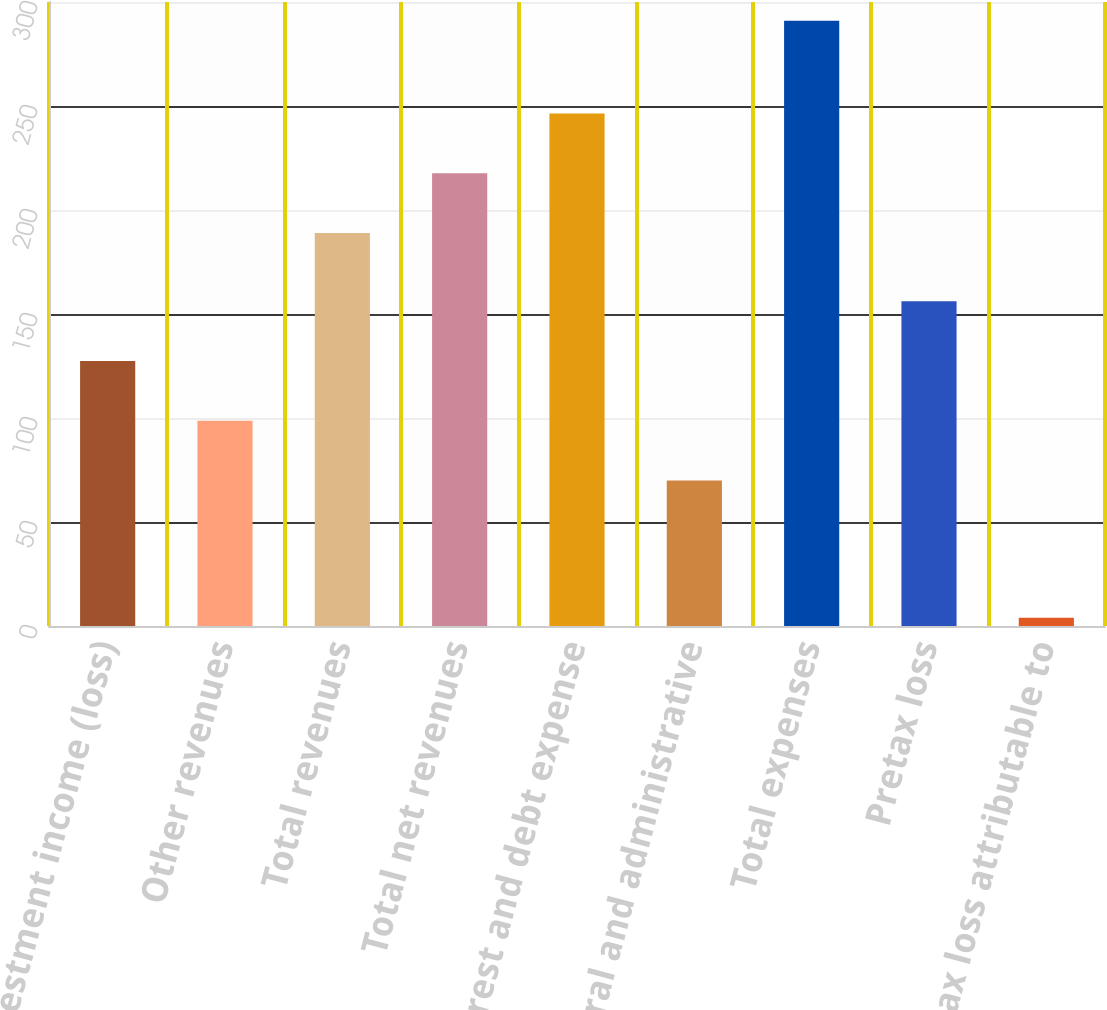Convert chart to OTSL. <chart><loc_0><loc_0><loc_500><loc_500><bar_chart><fcel>Net investment income (loss)<fcel>Other revenues<fcel>Total revenues<fcel>Total net revenues<fcel>Interest and debt expense<fcel>General and administrative<fcel>Total expenses<fcel>Pretax loss<fcel>Pretax loss attributable to<nl><fcel>127.4<fcel>98.7<fcel>189<fcel>217.7<fcel>246.4<fcel>70<fcel>291<fcel>156.1<fcel>4<nl></chart> 